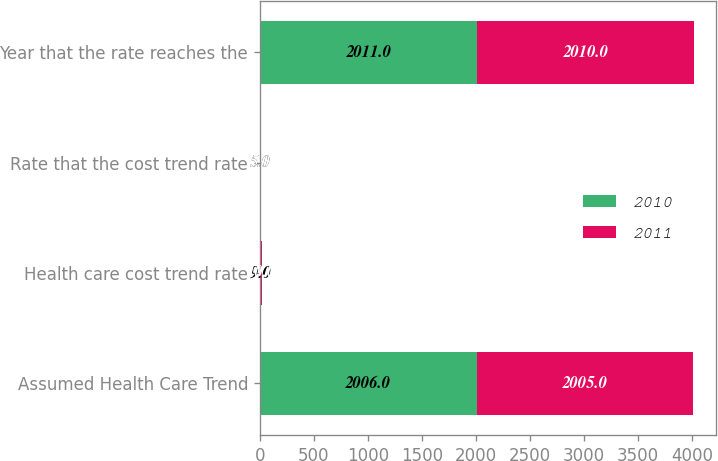Convert chart to OTSL. <chart><loc_0><loc_0><loc_500><loc_500><stacked_bar_chart><ecel><fcel>Assumed Health Care Trend<fcel>Health care cost trend rate<fcel>Rate that the cost trend rate<fcel>Year that the rate reaches the<nl><fcel>2010<fcel>2006<fcel>9<fcel>5<fcel>2011<nl><fcel>2011<fcel>2005<fcel>10<fcel>5<fcel>2010<nl></chart> 